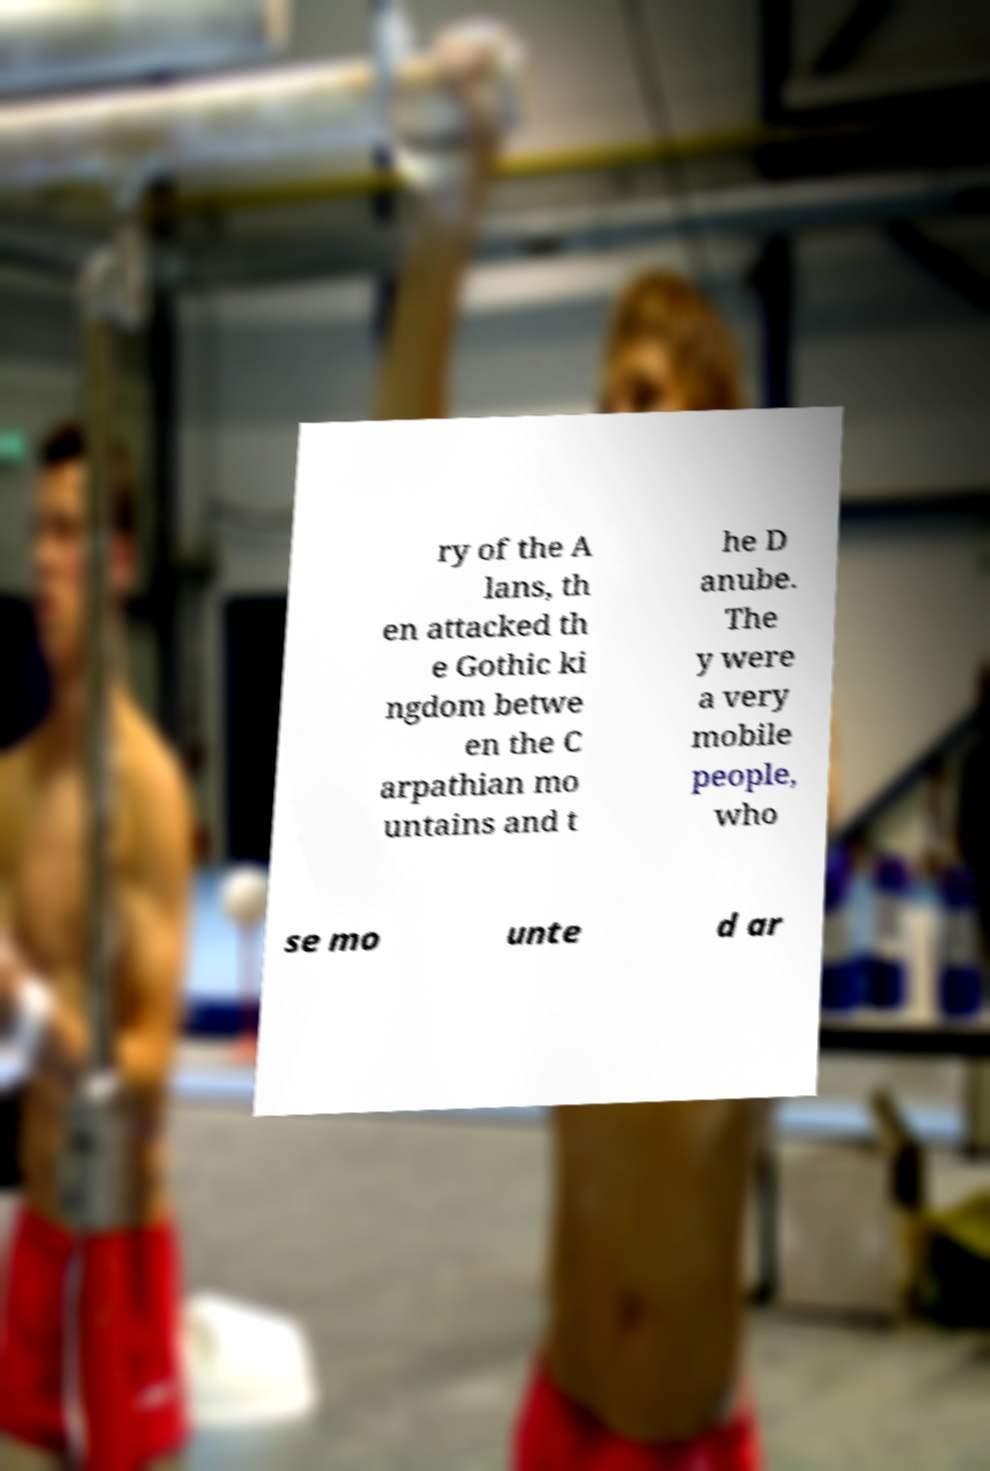Can you read and provide the text displayed in the image?This photo seems to have some interesting text. Can you extract and type it out for me? ry of the A lans, th en attacked th e Gothic ki ngdom betwe en the C arpathian mo untains and t he D anube. The y were a very mobile people, who se mo unte d ar 